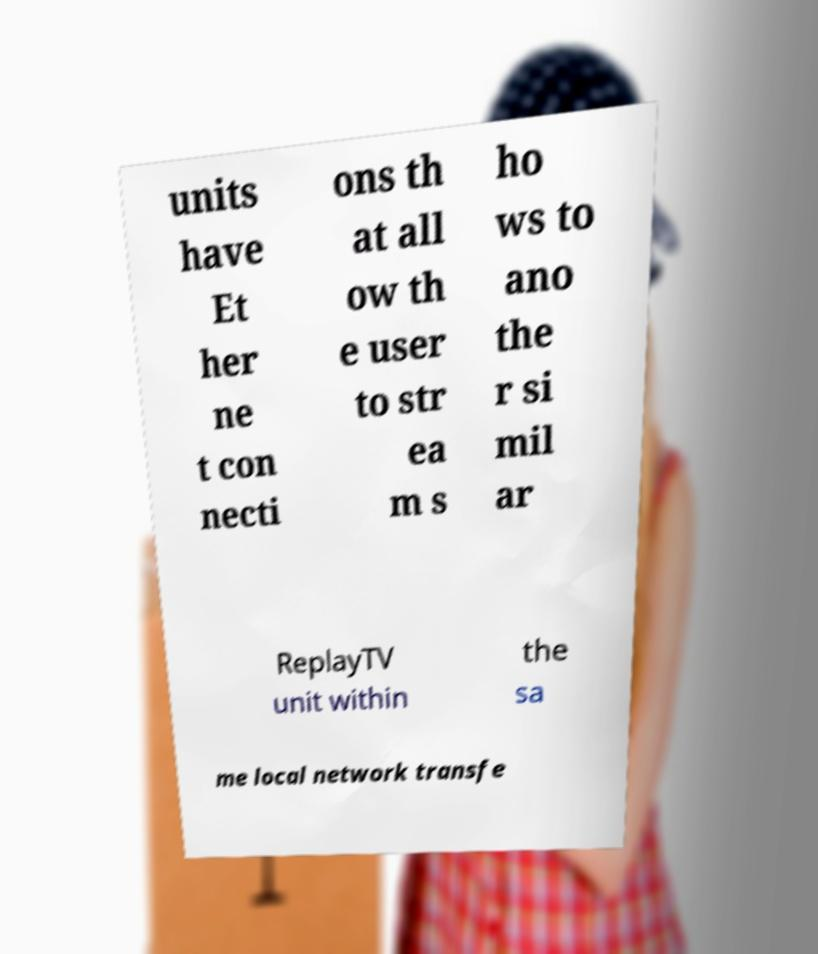I need the written content from this picture converted into text. Can you do that? units have Et her ne t con necti ons th at all ow th e user to str ea m s ho ws to ano the r si mil ar ReplayTV unit within the sa me local network transfe 